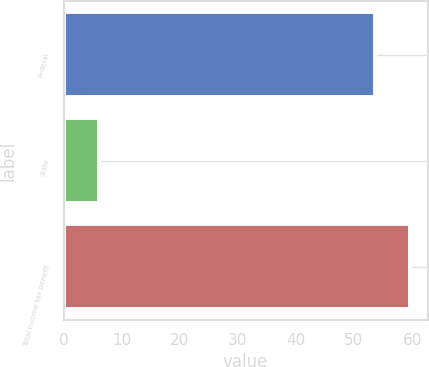Convert chart. <chart><loc_0><loc_0><loc_500><loc_500><bar_chart><fcel>Federal<fcel>State<fcel>Total income tax benefit<nl><fcel>53.6<fcel>6.1<fcel>59.7<nl></chart> 